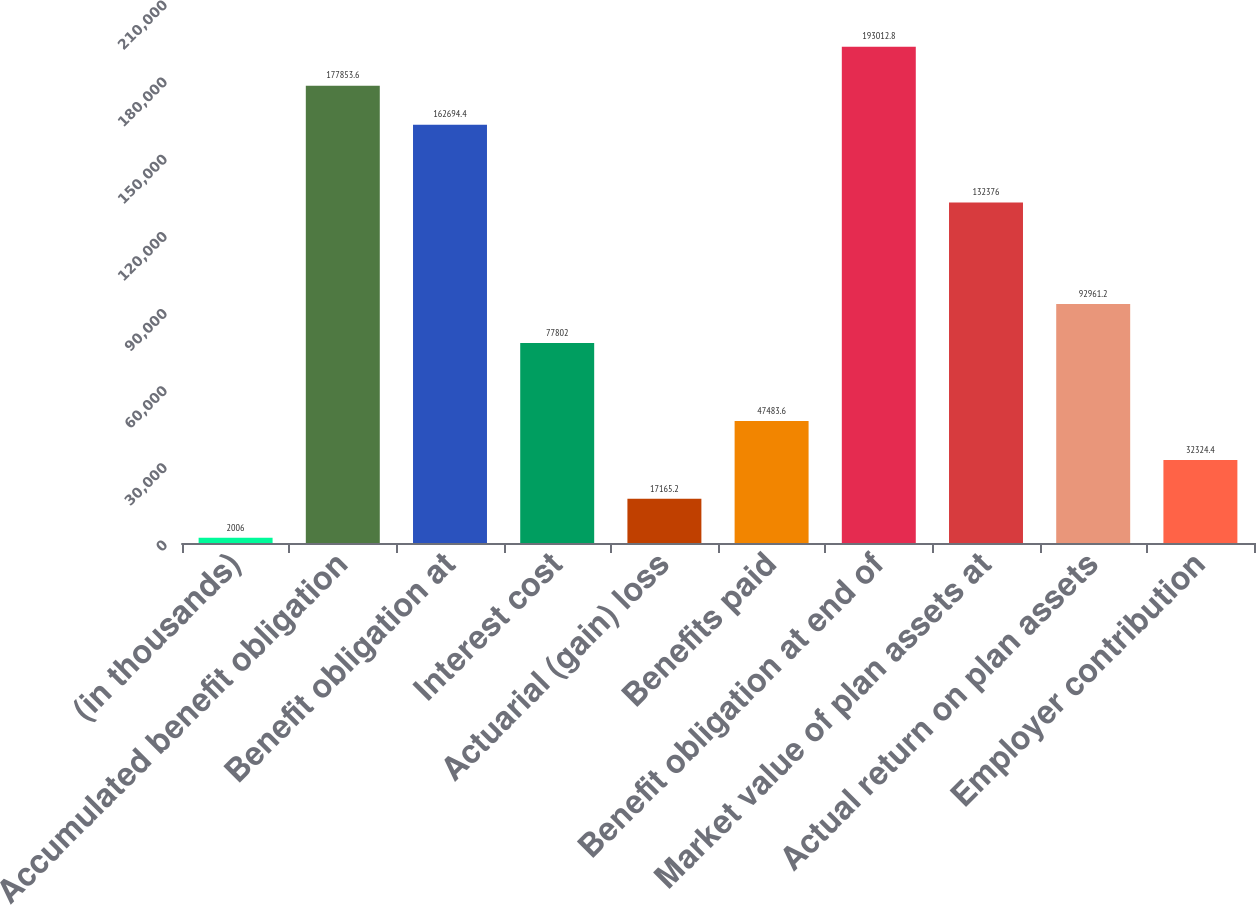<chart> <loc_0><loc_0><loc_500><loc_500><bar_chart><fcel>(in thousands)<fcel>Accumulated benefit obligation<fcel>Benefit obligation at<fcel>Interest cost<fcel>Actuarial (gain) loss<fcel>Benefits paid<fcel>Benefit obligation at end of<fcel>Market value of plan assets at<fcel>Actual return on plan assets<fcel>Employer contribution<nl><fcel>2006<fcel>177854<fcel>162694<fcel>77802<fcel>17165.2<fcel>47483.6<fcel>193013<fcel>132376<fcel>92961.2<fcel>32324.4<nl></chart> 